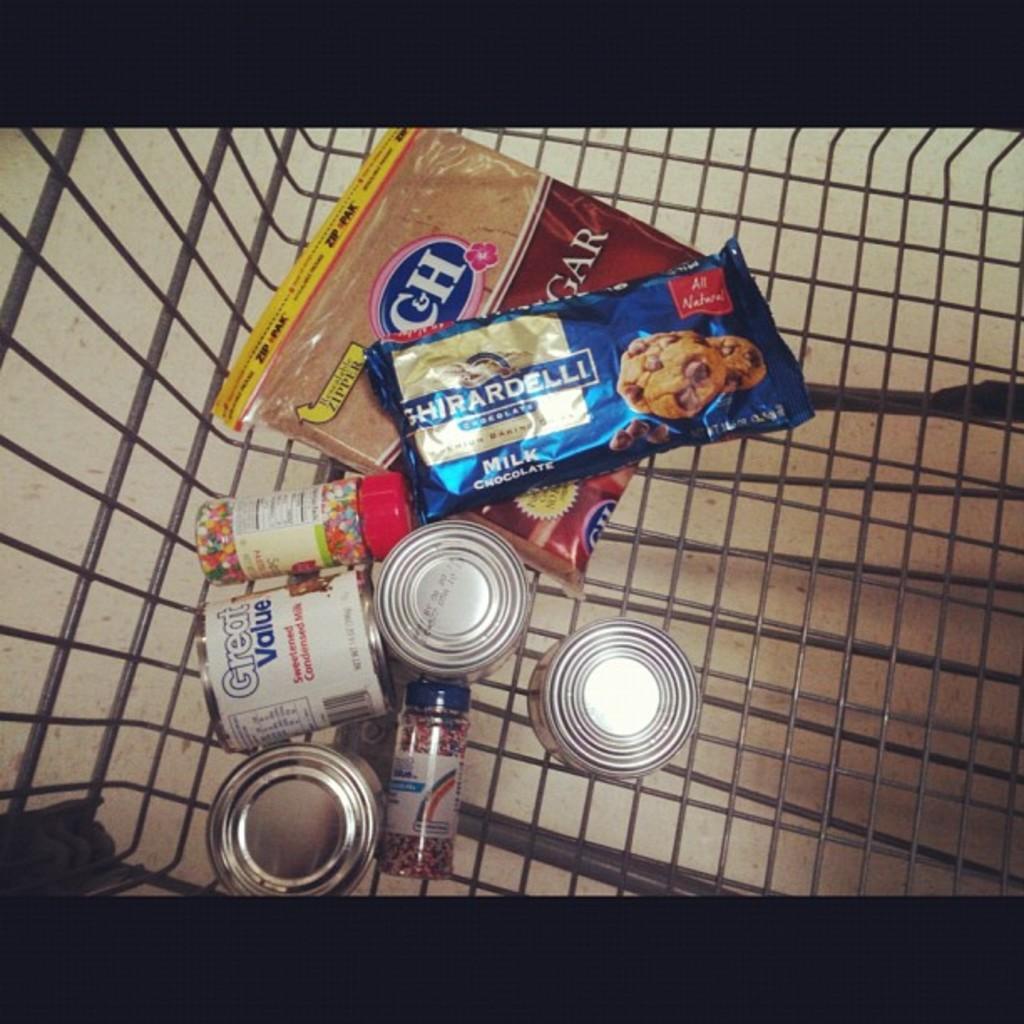Can you describe this image briefly? This picture seems to be an edited image with the black borders. In the center we can see the metal object containing the cookie packet, glass jars of some food items and we can see the cans of food items. In the background we can see an object which seems to be the ground and we can see some other items. 